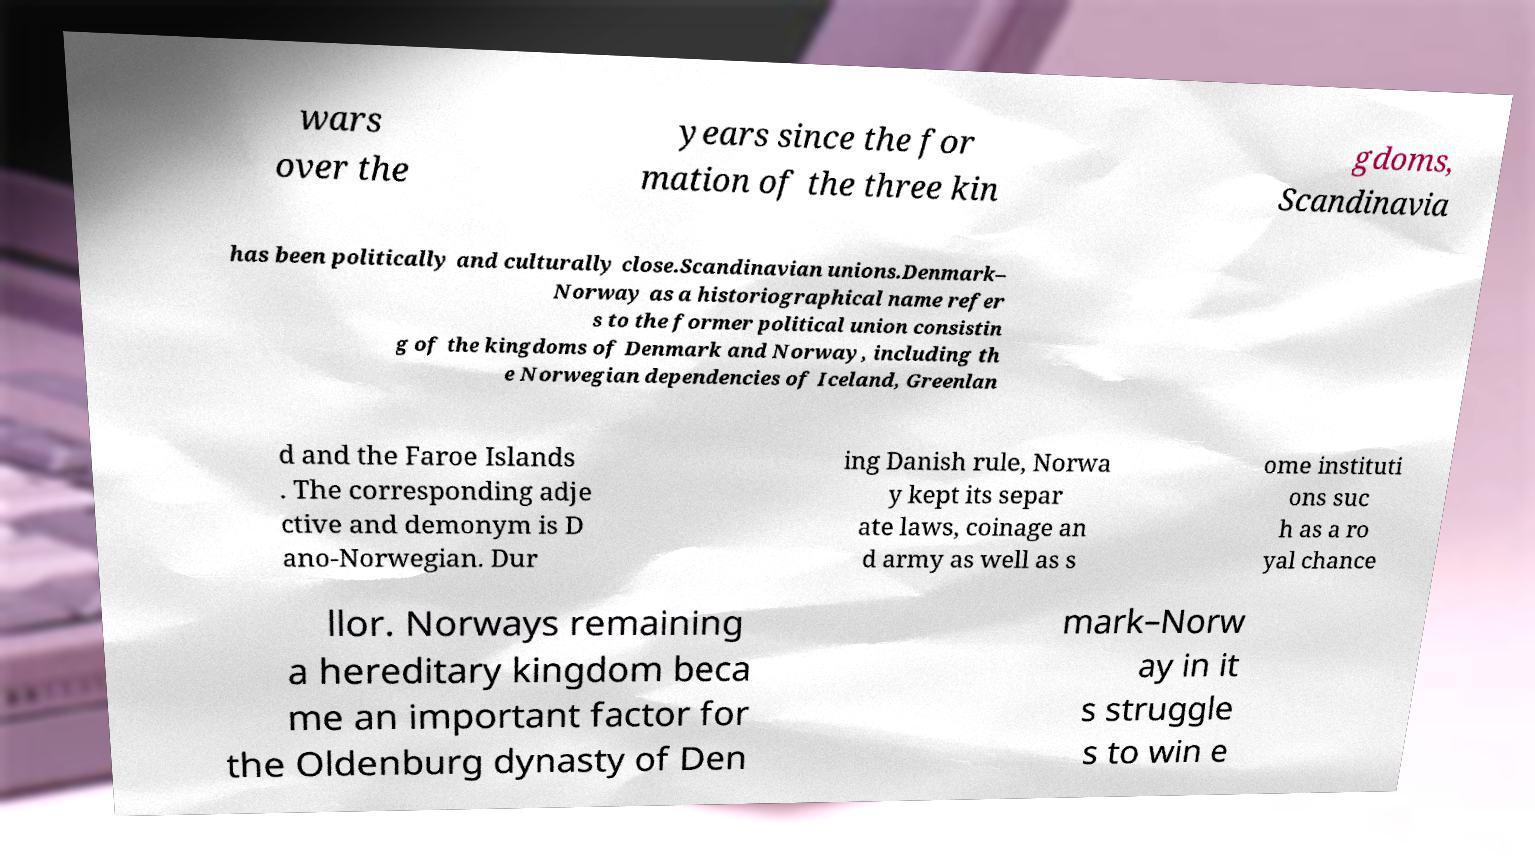There's text embedded in this image that I need extracted. Can you transcribe it verbatim? wars over the years since the for mation of the three kin gdoms, Scandinavia has been politically and culturally close.Scandinavian unions.Denmark– Norway as a historiographical name refer s to the former political union consistin g of the kingdoms of Denmark and Norway, including th e Norwegian dependencies of Iceland, Greenlan d and the Faroe Islands . The corresponding adje ctive and demonym is D ano-Norwegian. Dur ing Danish rule, Norwa y kept its separ ate laws, coinage an d army as well as s ome instituti ons suc h as a ro yal chance llor. Norways remaining a hereditary kingdom beca me an important factor for the Oldenburg dynasty of Den mark–Norw ay in it s struggle s to win e 